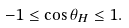<formula> <loc_0><loc_0><loc_500><loc_500>- 1 \leq \cos \theta _ { H } \leq 1 .</formula> 